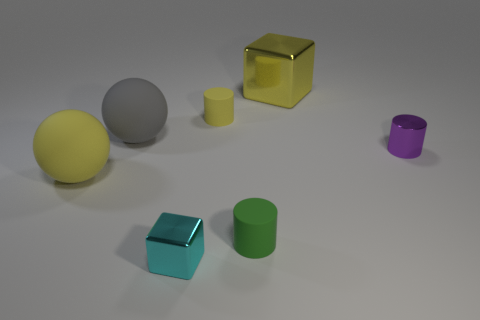What number of metal objects are in front of the purple cylinder and behind the purple cylinder?
Provide a succinct answer. 0. What number of objects are either tiny green matte cylinders or small blocks that are in front of the tiny purple object?
Keep it short and to the point. 2. Are there more cyan objects than big rubber things?
Give a very brief answer. No. There is a tiny matte object behind the tiny purple thing; what is its shape?
Ensure brevity in your answer.  Cylinder. How many big yellow rubber objects are the same shape as the gray thing?
Ensure brevity in your answer.  1. What is the size of the thing left of the matte sphere that is behind the tiny purple cylinder?
Your answer should be compact. Large. What number of gray objects are balls or small metal balls?
Give a very brief answer. 1. Are there fewer big gray things in front of the tiny purple shiny cylinder than small cylinders that are in front of the cyan cube?
Your response must be concise. No. Is the size of the purple metal object the same as the sphere that is in front of the big gray matte object?
Your answer should be compact. No. How many red matte balls are the same size as the purple object?
Make the answer very short. 0. 